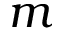Convert formula to latex. <formula><loc_0><loc_0><loc_500><loc_500>m</formula> 